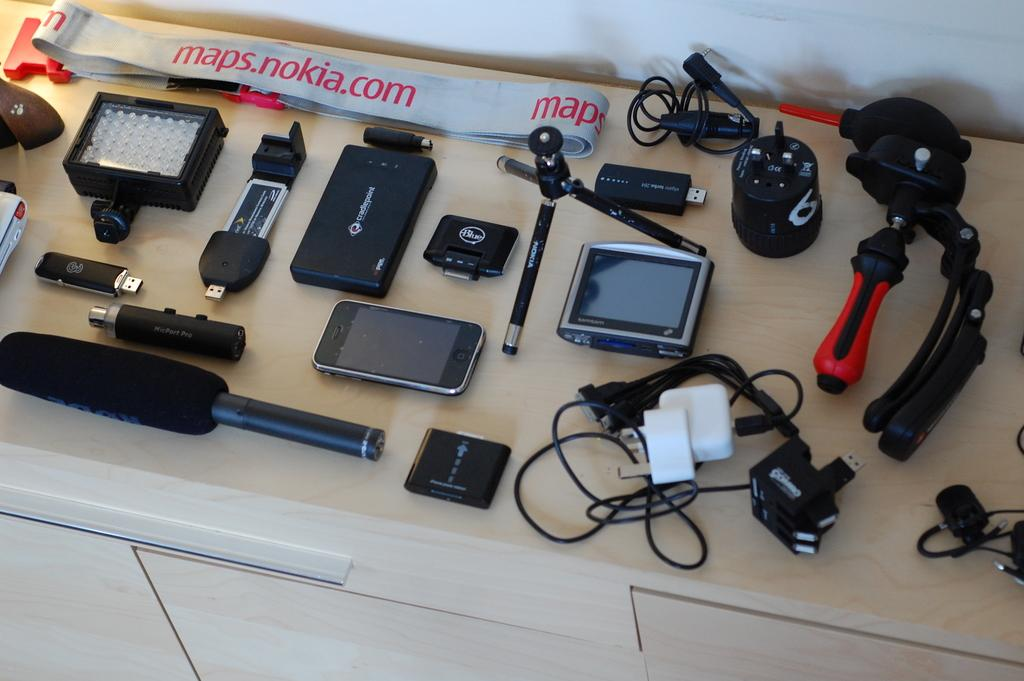<image>
Create a compact narrative representing the image presented. A collection of electronics and a strap of fabric saying nokia. 